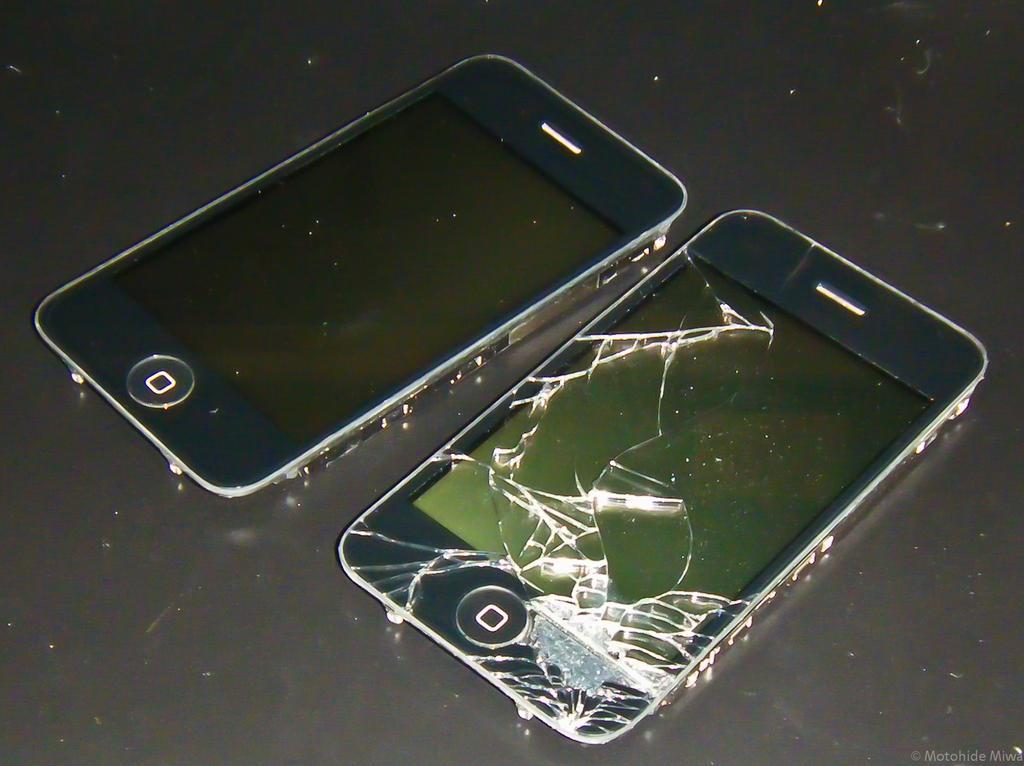How would you summarize this image in a sentence or two? In this image we can see two mobiles placed on the surface 